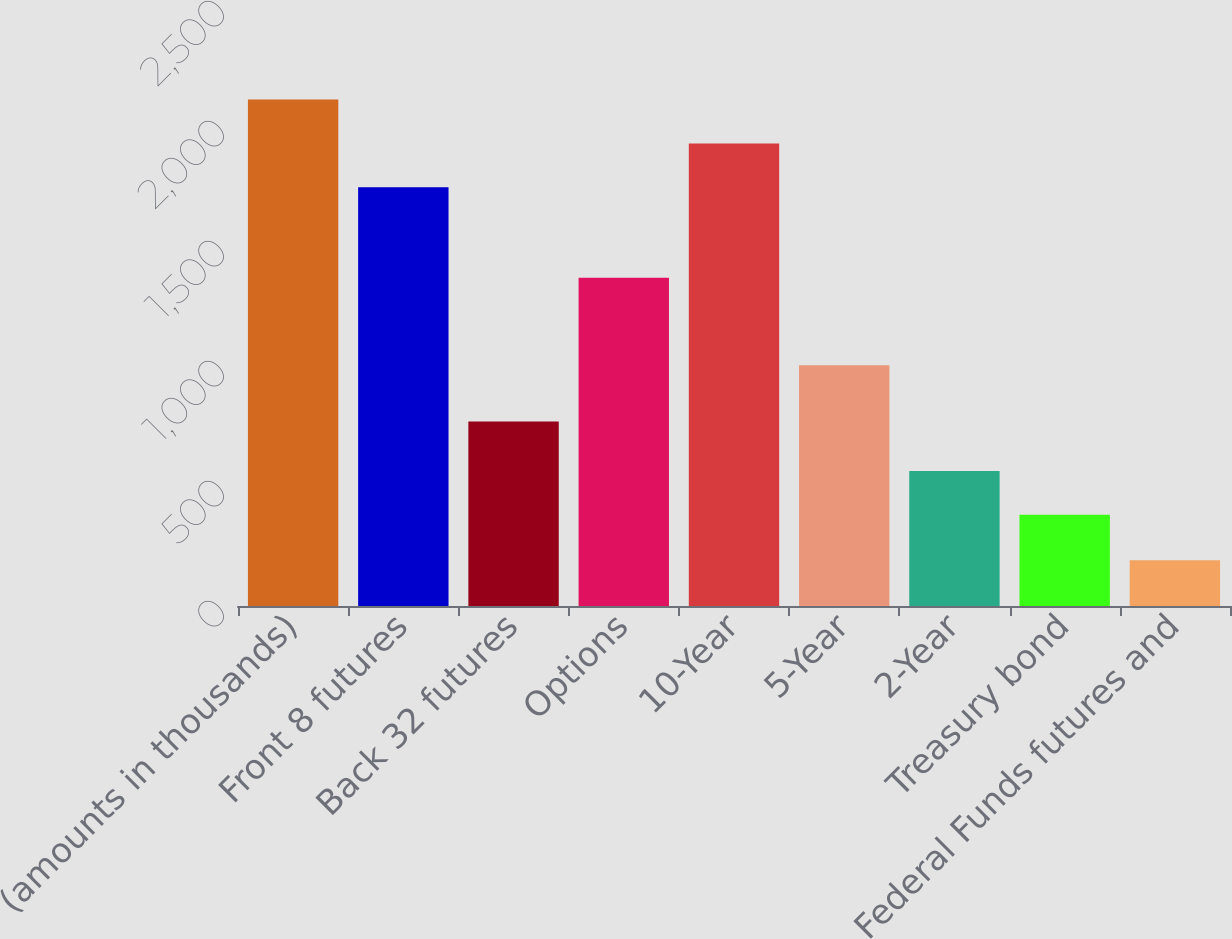Convert chart. <chart><loc_0><loc_0><loc_500><loc_500><bar_chart><fcel>(amounts in thousands)<fcel>Front 8 futures<fcel>Back 32 futures<fcel>Options<fcel>10-Year<fcel>5-Year<fcel>2-Year<fcel>Treasury bond<fcel>Federal Funds futures and<nl><fcel>2110.2<fcel>1745<fcel>769<fcel>1368<fcel>1927.6<fcel>1003<fcel>562.6<fcel>380<fcel>191<nl></chart> 